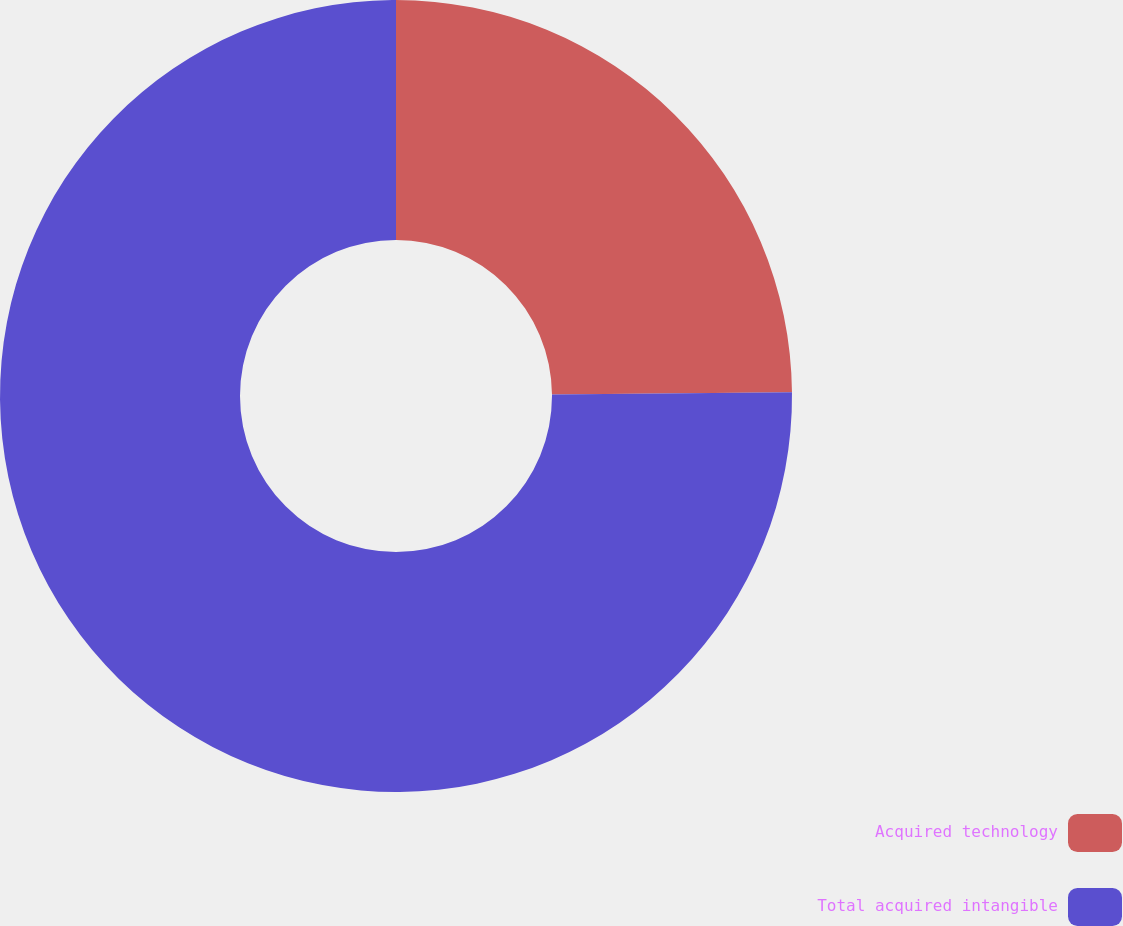<chart> <loc_0><loc_0><loc_500><loc_500><pie_chart><fcel>Acquired technology<fcel>Total acquired intangible<nl><fcel>24.85%<fcel>75.15%<nl></chart> 